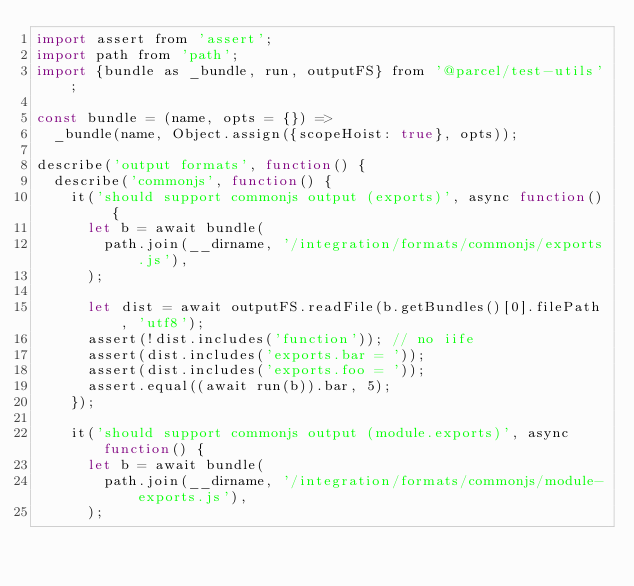<code> <loc_0><loc_0><loc_500><loc_500><_JavaScript_>import assert from 'assert';
import path from 'path';
import {bundle as _bundle, run, outputFS} from '@parcel/test-utils';

const bundle = (name, opts = {}) =>
  _bundle(name, Object.assign({scopeHoist: true}, opts));

describe('output formats', function() {
  describe('commonjs', function() {
    it('should support commonjs output (exports)', async function() {
      let b = await bundle(
        path.join(__dirname, '/integration/formats/commonjs/exports.js'),
      );

      let dist = await outputFS.readFile(b.getBundles()[0].filePath, 'utf8');
      assert(!dist.includes('function')); // no iife
      assert(dist.includes('exports.bar = '));
      assert(dist.includes('exports.foo = '));
      assert.equal((await run(b)).bar, 5);
    });

    it('should support commonjs output (module.exports)', async function() {
      let b = await bundle(
        path.join(__dirname, '/integration/formats/commonjs/module-exports.js'),
      );
</code> 